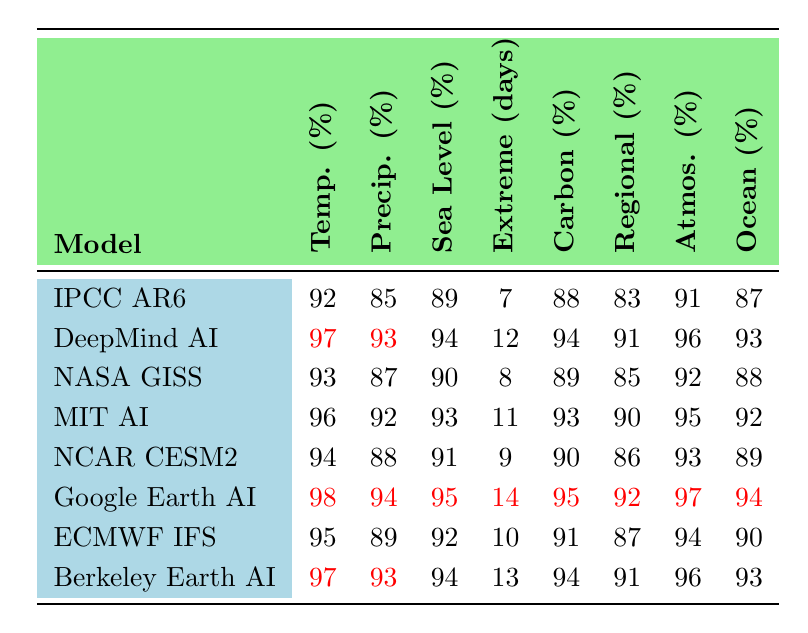What is the global temperature prediction accuracy of Google's Earth Engine AI? The value for Google's Earth Engine AI in the "Global temperature prediction accuracy (%)" row is 98.
Answer: 98% Which model has the highest sea level rise projection precision? By comparing the values under "Sea level rise projection precision (%)", Google's Earth Engine AI shows 95%, which is higher than all other models listed.
Answer: Google's Earth Engine AI What is the difference in extreme weather event prediction lead time between DeepMind's AI-enhanced model and the IPCC AR6 model? DeepMind's AI-enhanced model has a lead time of 12 days, while the IPCC AR6 model has 7 days. The difference is 12 - 7 = 5 days.
Answer: 5 days Is the carbon cycle modeling accuracy of NCAR CESM2 greater than 90%? The carbon cycle modeling accuracy for NCAR CESM2 is 90%. Since the accuracy is exactly 90%, we cannot say it is greater than 90%.
Answer: No What is the average precipitation pattern forecast improvement across all models? We sum up the precipitation improvement values: (85 + 93 + 87 + 92 + 88 + 94 + 89 + 93) = 719. There are 8 models, so the average is 719 / 8 = 89.875.
Answer: Approximately 89.9% Which model has the longest extreme weather event prediction lead time, and what is that lead time? By examining the "Extreme weather event prediction lead time (days)" row, we find Google's Earth Engine AI has the highest lead time of 14 days.
Answer: Google's Earth Engine AI with 14 days If we compare the atmospheric composition prediction accuracy of MIT's AI-Climate Forecaster and Berkeley Earth AI-Augmented, which one has a higher accuracy? The atmospheric composition prediction accuracy for MIT's AI-Climate Forecaster is 95%, while for Berkeley Earth AI-Augmented, it is 96%. Since 96% is greater than 95%, Berkeley Earth AI-Augmented has higher accuracy.
Answer: Berkeley Earth AI-Augmented What is the total improvement in ocean heat content estimation precision among all the models? Summing the values in the "Ocean heat content estimation precision (%)" row gives us (87 + 93 + 88 + 92 + 89 + 94 + 90 + 93) = 716.
Answer: 716% Which model offers the least improvement in precipitation pattern forecasting? Looking at the "Precipitation pattern forecast improvement (%)", IPCC AR6 has the lowest improvement at 85%.
Answer: IPCC AR6 What is the median global temperature prediction accuracy among all models? Sorting the values for global temperature prediction accuracy gives us: 92, 93, 94, 94, 95, 96, 97, 98. The median is the average of the two middle numbers (94 and 95), which is (94 + 95) / 2 = 94.5.
Answer: 94.5% 